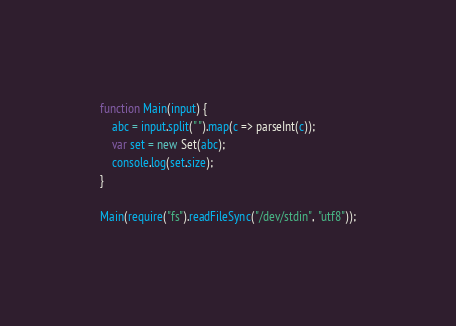Convert code to text. <code><loc_0><loc_0><loc_500><loc_500><_JavaScript_>function Main(input) {
	abc = input.split(" ").map(c => parseInt(c));
	var set = new Set(abc);
  	console.log(set.size);
}

Main(require("fs").readFileSync("/dev/stdin", "utf8"));</code> 